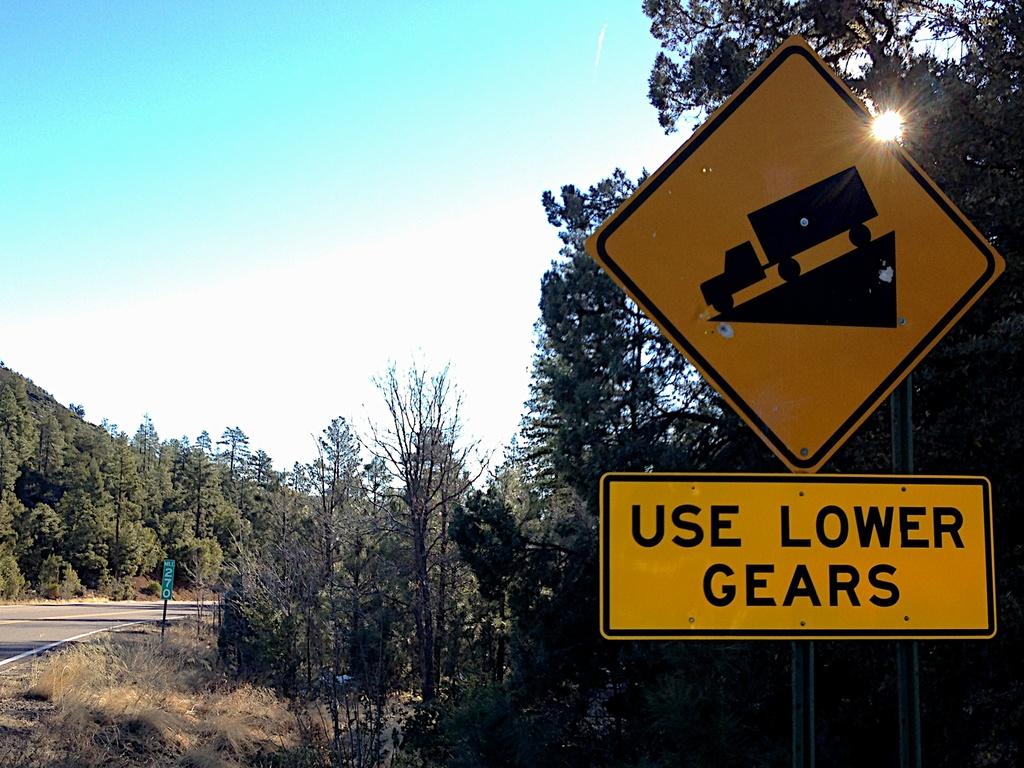What is the sign instructing us to do?
Give a very brief answer. Use lower gears. 